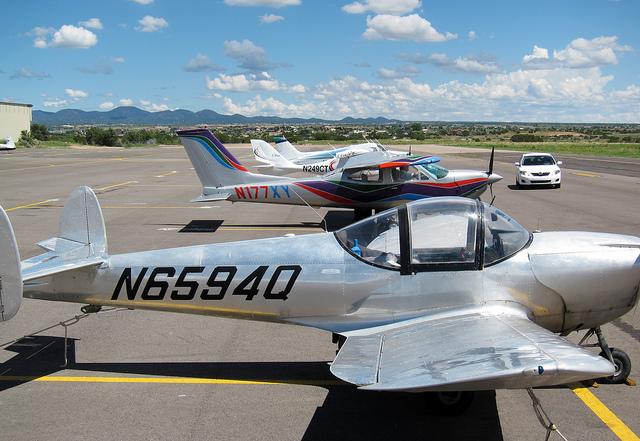What is written on the tail of the nearest plane?
Quick response, please. N6594q. Is the sky cloudy?
Concise answer only. Yes. What is the number of the plane in the foreground?
Answer briefly. N6594q. Why are there stripes on the runway?
Answer briefly. Parking. 